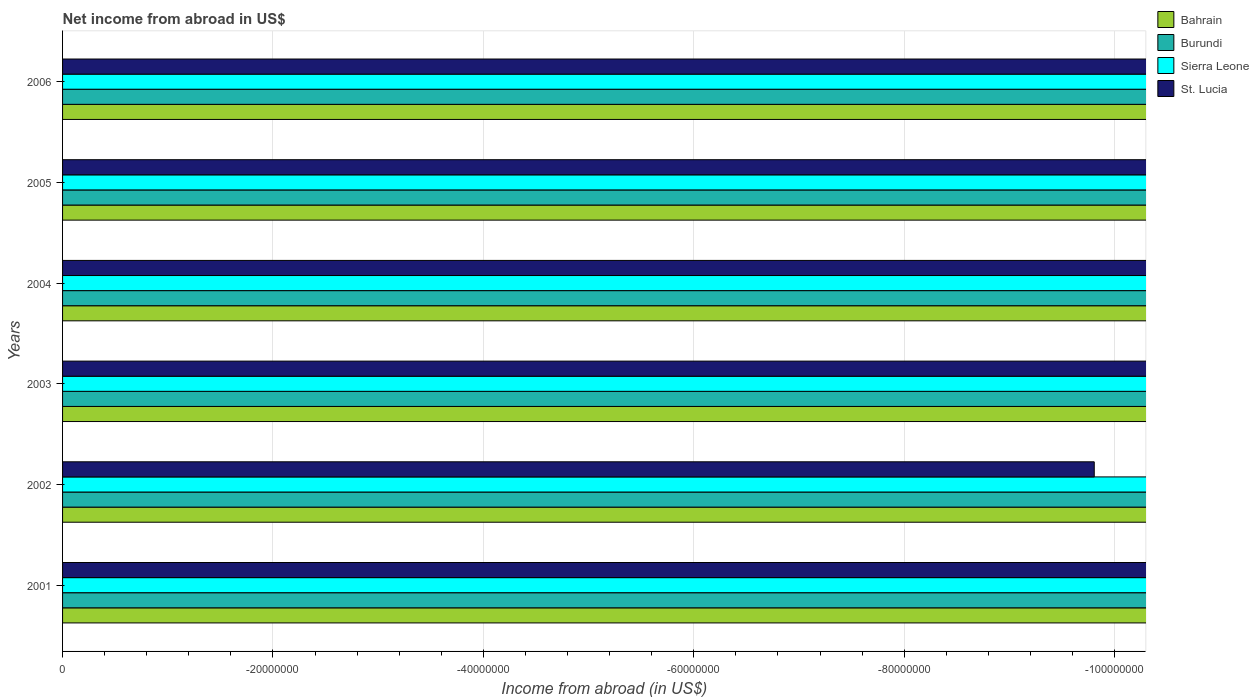How many different coloured bars are there?
Keep it short and to the point. 0. Are the number of bars per tick equal to the number of legend labels?
Ensure brevity in your answer.  No. How many bars are there on the 4th tick from the top?
Give a very brief answer. 0. In how many cases, is the number of bars for a given year not equal to the number of legend labels?
Keep it short and to the point. 6. What is the total net income from abroad in Bahrain in the graph?
Ensure brevity in your answer.  0. In how many years, is the net income from abroad in Burundi greater than -68000000 US$?
Offer a terse response. 0. In how many years, is the net income from abroad in Sierra Leone greater than the average net income from abroad in Sierra Leone taken over all years?
Provide a short and direct response. 0. Is it the case that in every year, the sum of the net income from abroad in Bahrain and net income from abroad in Burundi is greater than the sum of net income from abroad in St. Lucia and net income from abroad in Sierra Leone?
Keep it short and to the point. No. Is it the case that in every year, the sum of the net income from abroad in Sierra Leone and net income from abroad in Burundi is greater than the net income from abroad in Bahrain?
Your response must be concise. No. Are all the bars in the graph horizontal?
Ensure brevity in your answer.  Yes. How many years are there in the graph?
Give a very brief answer. 6. Does the graph contain any zero values?
Provide a succinct answer. Yes. How many legend labels are there?
Your response must be concise. 4. How are the legend labels stacked?
Provide a succinct answer. Vertical. What is the title of the graph?
Ensure brevity in your answer.  Net income from abroad in US$. What is the label or title of the X-axis?
Provide a short and direct response. Income from abroad (in US$). What is the label or title of the Y-axis?
Give a very brief answer. Years. What is the Income from abroad (in US$) of Burundi in 2001?
Your response must be concise. 0. What is the Income from abroad (in US$) of Sierra Leone in 2001?
Offer a terse response. 0. What is the Income from abroad (in US$) in Burundi in 2002?
Give a very brief answer. 0. What is the Income from abroad (in US$) of Burundi in 2003?
Make the answer very short. 0. What is the Income from abroad (in US$) of Sierra Leone in 2003?
Give a very brief answer. 0. What is the Income from abroad (in US$) of Bahrain in 2004?
Ensure brevity in your answer.  0. What is the Income from abroad (in US$) of Sierra Leone in 2004?
Provide a succinct answer. 0. What is the Income from abroad (in US$) in St. Lucia in 2004?
Ensure brevity in your answer.  0. What is the Income from abroad (in US$) in Burundi in 2005?
Your response must be concise. 0. What is the Income from abroad (in US$) in Bahrain in 2006?
Offer a terse response. 0. What is the Income from abroad (in US$) in Burundi in 2006?
Offer a very short reply. 0. What is the Income from abroad (in US$) in Sierra Leone in 2006?
Provide a succinct answer. 0. What is the total Income from abroad (in US$) of Bahrain in the graph?
Your response must be concise. 0. What is the total Income from abroad (in US$) in Burundi in the graph?
Offer a very short reply. 0. What is the total Income from abroad (in US$) of Sierra Leone in the graph?
Your response must be concise. 0. What is the average Income from abroad (in US$) in Bahrain per year?
Your answer should be compact. 0. What is the average Income from abroad (in US$) in Sierra Leone per year?
Ensure brevity in your answer.  0. 